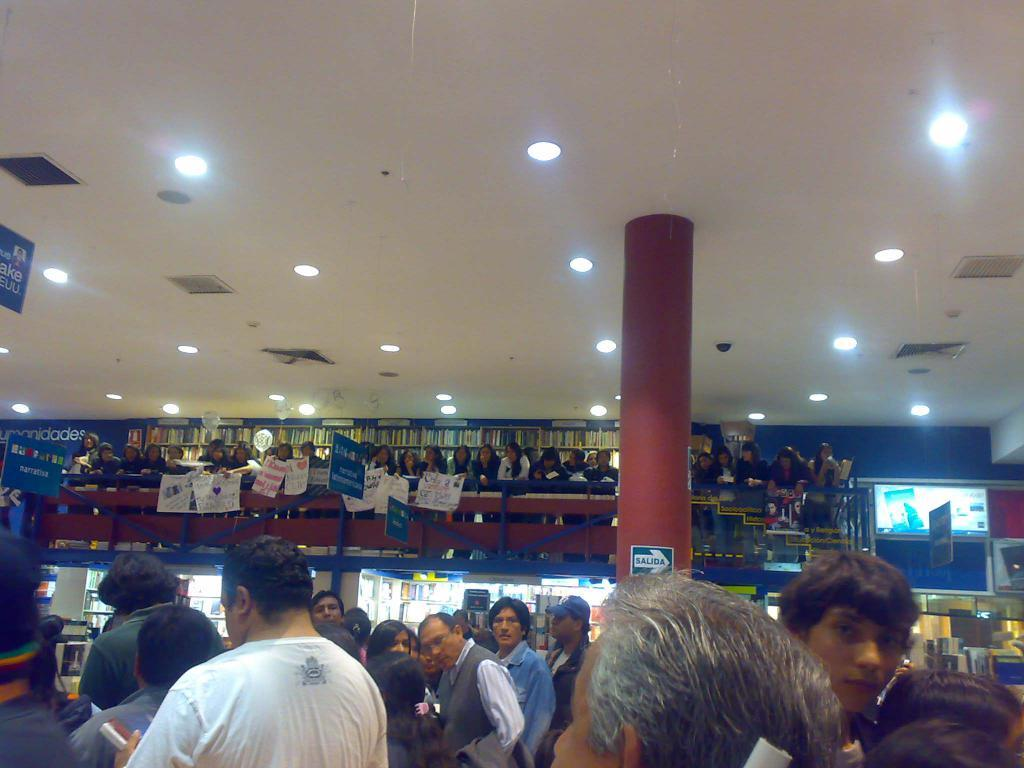How many people are present in the image? There are people in the image, but the exact number is not specified. What are the people on top of the structure doing? Some people are standing on top and holding boards. What can be seen in the image besides the people? There is a pillar in the image. What is visible at the top of the image? There are lights at the top of the image. What type of cakes are being served at the event in the image? There is no mention of cakes or an event in the image; it features people standing on top of a structure and holding boards. Is there any poison visible in the image? There is no indication of poison or any dangerous substances in the image. 